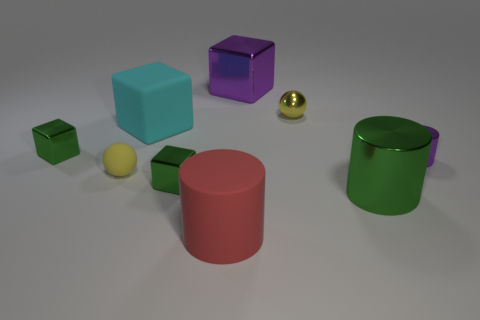What size is the metallic thing that is the same color as the small metal cylinder?
Offer a very short reply. Large. Is the number of small green shiny objects greater than the number of cubes?
Provide a succinct answer. No. Does the large rubber cube have the same color as the matte cylinder?
Ensure brevity in your answer.  No. What number of objects are purple objects or small things that are behind the purple cylinder?
Offer a very short reply. 4. What number of other objects are the same shape as the small matte object?
Your response must be concise. 1. Is the number of tiny yellow rubber balls that are on the right side of the small purple metal thing less than the number of yellow rubber things that are in front of the yellow metallic ball?
Provide a succinct answer. Yes. What is the shape of the yellow object that is made of the same material as the purple block?
Make the answer very short. Sphere. Are there any other things that are the same color as the shiny ball?
Your response must be concise. Yes. The cylinder left of the tiny yellow ball right of the big purple metal block is what color?
Provide a short and direct response. Red. There is a green block that is right of the tiny sphere that is on the left side of the small yellow ball that is right of the cyan rubber cube; what is it made of?
Ensure brevity in your answer.  Metal. 